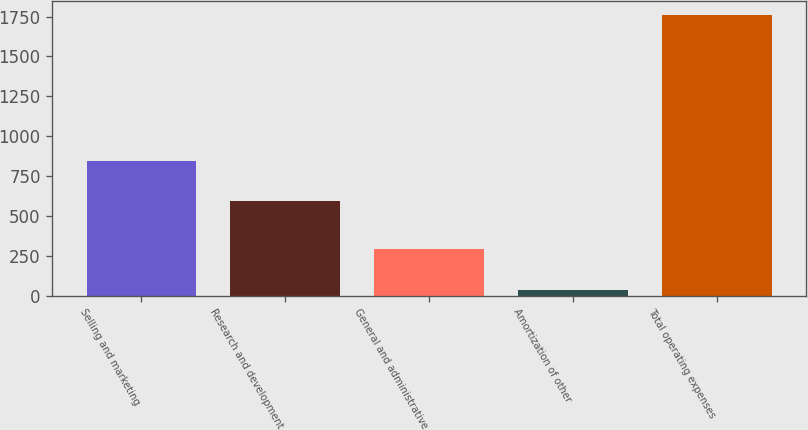<chart> <loc_0><loc_0><loc_500><loc_500><bar_chart><fcel>Selling and marketing<fcel>Research and development<fcel>General and administrative<fcel>Amortization of other<fcel>Total operating expenses<nl><fcel>841<fcel>593<fcel>290<fcel>35<fcel>1759<nl></chart> 